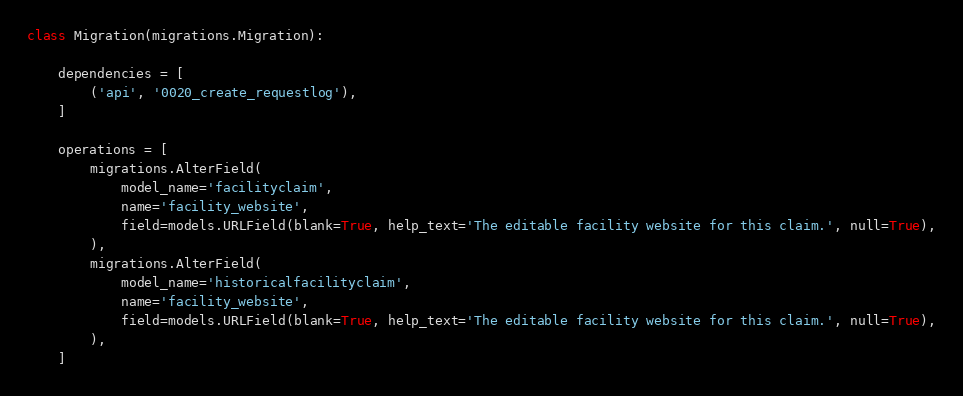Convert code to text. <code><loc_0><loc_0><loc_500><loc_500><_Python_>class Migration(migrations.Migration):

    dependencies = [
        ('api', '0020_create_requestlog'),
    ]

    operations = [
        migrations.AlterField(
            model_name='facilityclaim',
            name='facility_website',
            field=models.URLField(blank=True, help_text='The editable facility website for this claim.', null=True),
        ),
        migrations.AlterField(
            model_name='historicalfacilityclaim',
            name='facility_website',
            field=models.URLField(blank=True, help_text='The editable facility website for this claim.', null=True),
        ),
    ]
</code> 